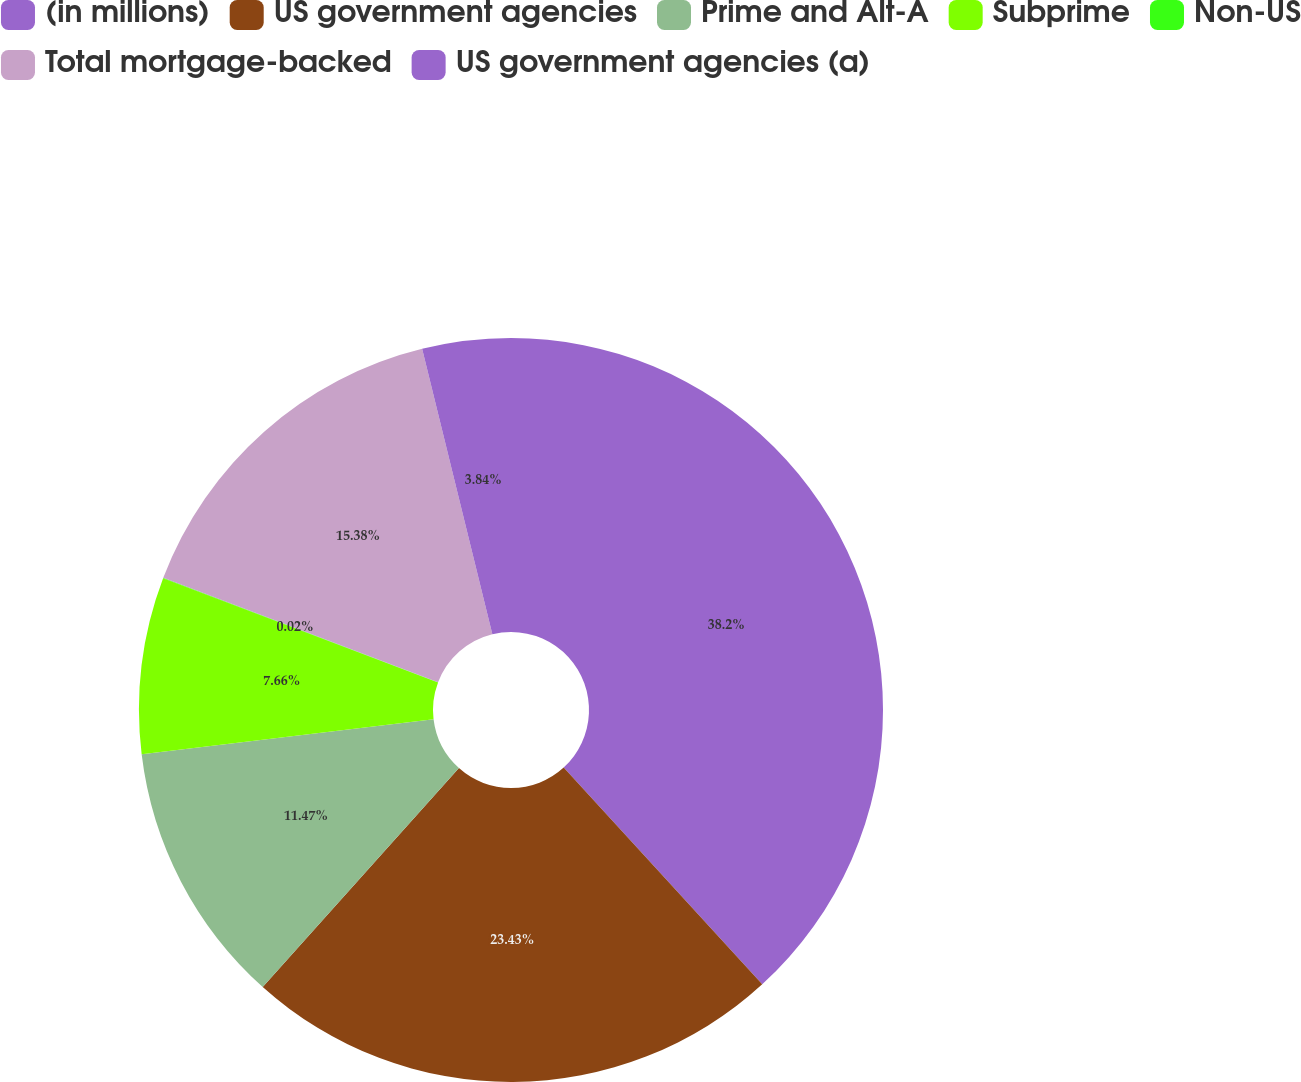<chart> <loc_0><loc_0><loc_500><loc_500><pie_chart><fcel>(in millions)<fcel>US government agencies<fcel>Prime and Alt-A<fcel>Subprime<fcel>Non-US<fcel>Total mortgage-backed<fcel>US government agencies (a)<nl><fcel>38.2%<fcel>23.43%<fcel>11.47%<fcel>7.66%<fcel>0.02%<fcel>15.38%<fcel>3.84%<nl></chart> 